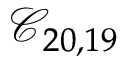Convert formula to latex. <formula><loc_0><loc_0><loc_500><loc_500>\mathcal { C } _ { 2 0 , 1 9 }</formula> 